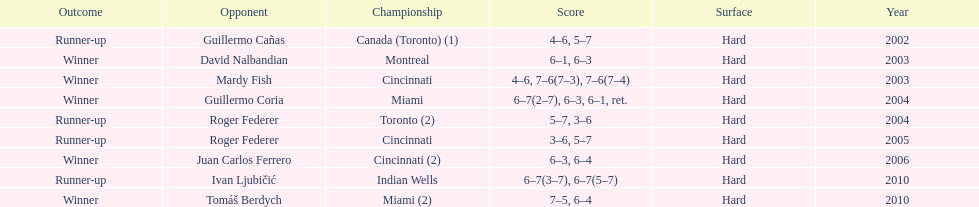What is his highest number of consecutive wins? 3. 